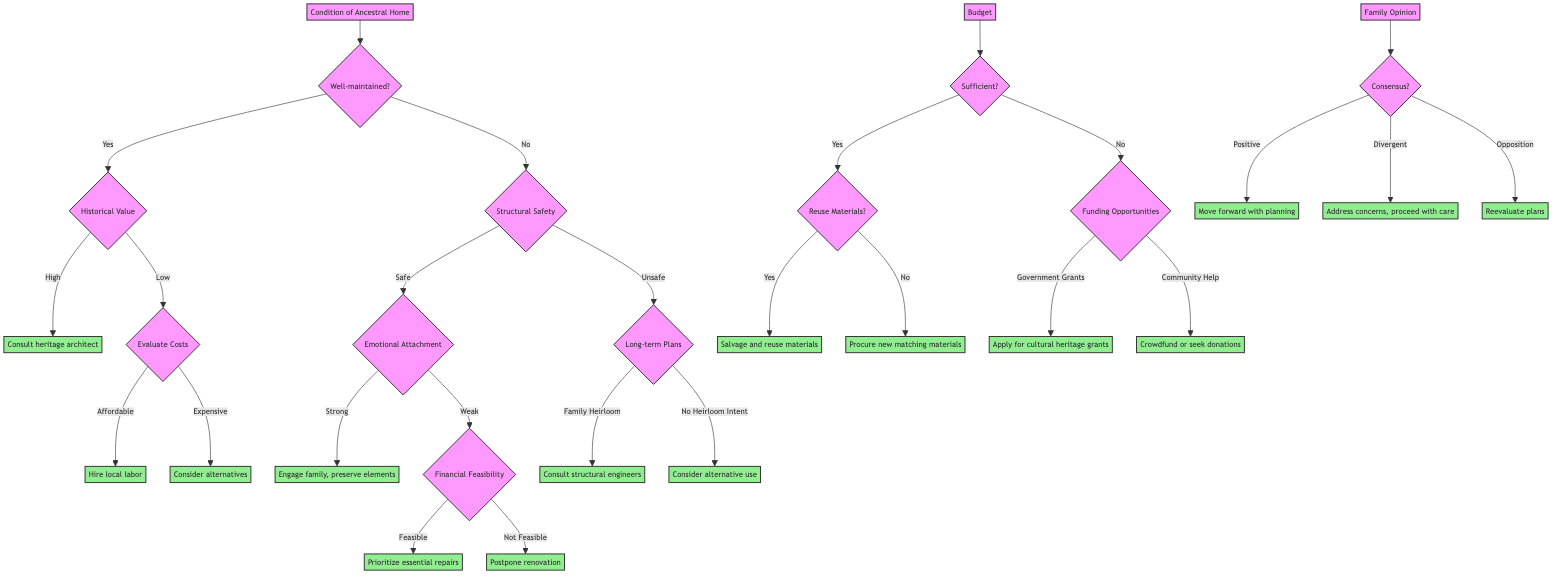What are the two main categories under the Condition of Ancestral Home node? The diagram shows two main categories under the "Condition of Ancestral Home" node: "Well-maintained" and "Deteriorated". These represent the initial decision factors regarding the state of the ancestral home.
Answer: Well-maintained, Deteriorated What happens if the ancestral home is classified as Well-maintained and has High Historical Value? If the home is classified as Well-maintained with High Historical Value, the next step is to consult a heritage architect as indicated in the decision tree.
Answer: Consult a heritage architect What is the outcome if there is Divergent family opinion but a Majority Support? In the case of Divergent family opinion, if there is Majority Support, the decision is to address the concerns of dissenting family members and proceed with care.
Answer: Address concerns, proceed with care How many outcomes are there for the Budget node if it is Limited? The Budget node splits into two outcomes when it is Limited: "Funding Opportunities" with two branches (Government Grants and Community Help), which results in a total of three distinct decision paths.
Answer: Three What needs to be evaluated if the Condition of the Ancestral Home is Deteriorated and the Structural Safety is Safe with Weak Emotional Attachment? In this case, it directs to evaluate the Financial Feasibility, leading to a decision on whether it is Feasible or Not Feasible, determining the next steps in the renovation process.
Answer: Evaluate Financial Feasibility If the Budget is Sufficient and the materials are reused, what action should be taken? If the Budget is Sufficient and the decision is made to reuse materials, the action to take is to salvage and reuse materials from the ancestral home.
Answer: Salvage and reuse materials What will be the outcome if the Structural Safety is Unsafe and there is no Heirloom Intent? If the Structural Safety is classified as Unsafe and there is no Heirloom Intent, the outcome is to consider alternative use for the property or selling it.
Answer: Consider alternative use Which option is preferred if the Budget is Limited and eligible for Government Grants? If the Budget is Limited and the property is eligible for Government Grants, the preferred option is to apply for grants aimed at preserving cultural heritage.
Answer: Apply for cultural heritage grants 